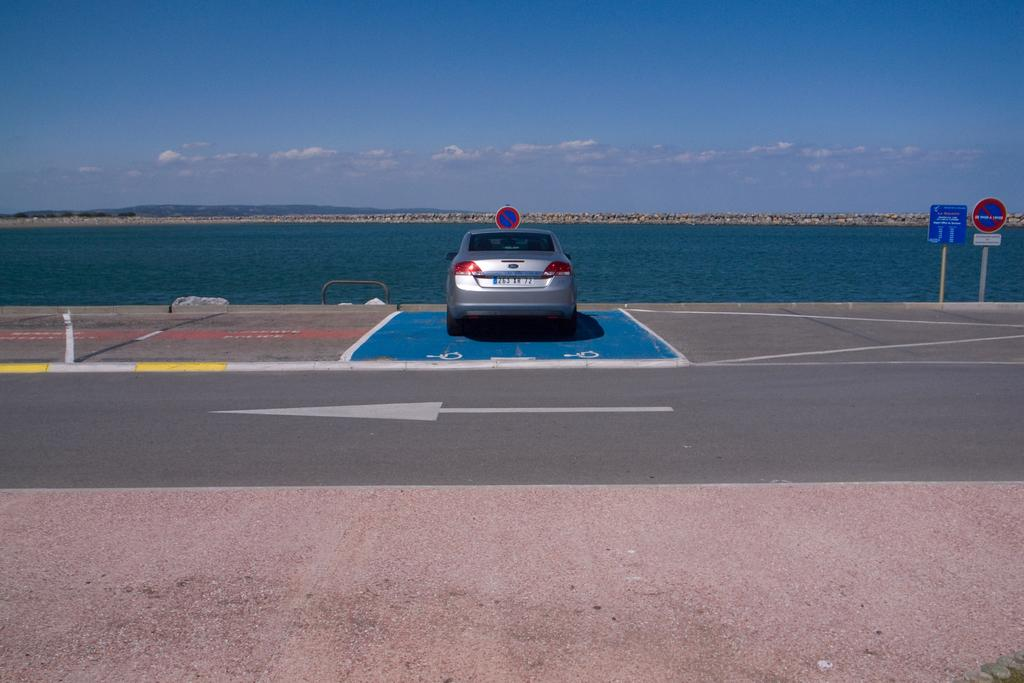What can be seen in the sky in the image? The sky with clouds is visible in the image. What type of natural feature is present in the image? There are hills in the image. What body of water is visible in the image? There is water visible in the image. What type of man-made object is present in the image? A sign board is present in the image. What mode of transportation is present in the image? A motor vehicle is on the road in the image. What safety feature is present in the image? Barriers are present in the image. Can you see a squirrel running on the road in the image? There is no squirrel present in the image, and therefore no such activity can be observed. What is the friction between the motor vehicle and the road in the image? The image does not provide information about the friction between the motor vehicle and the road. 